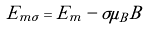Convert formula to latex. <formula><loc_0><loc_0><loc_500><loc_500>E _ { m \sigma } = E _ { m } - \sigma \mu _ { B } B</formula> 